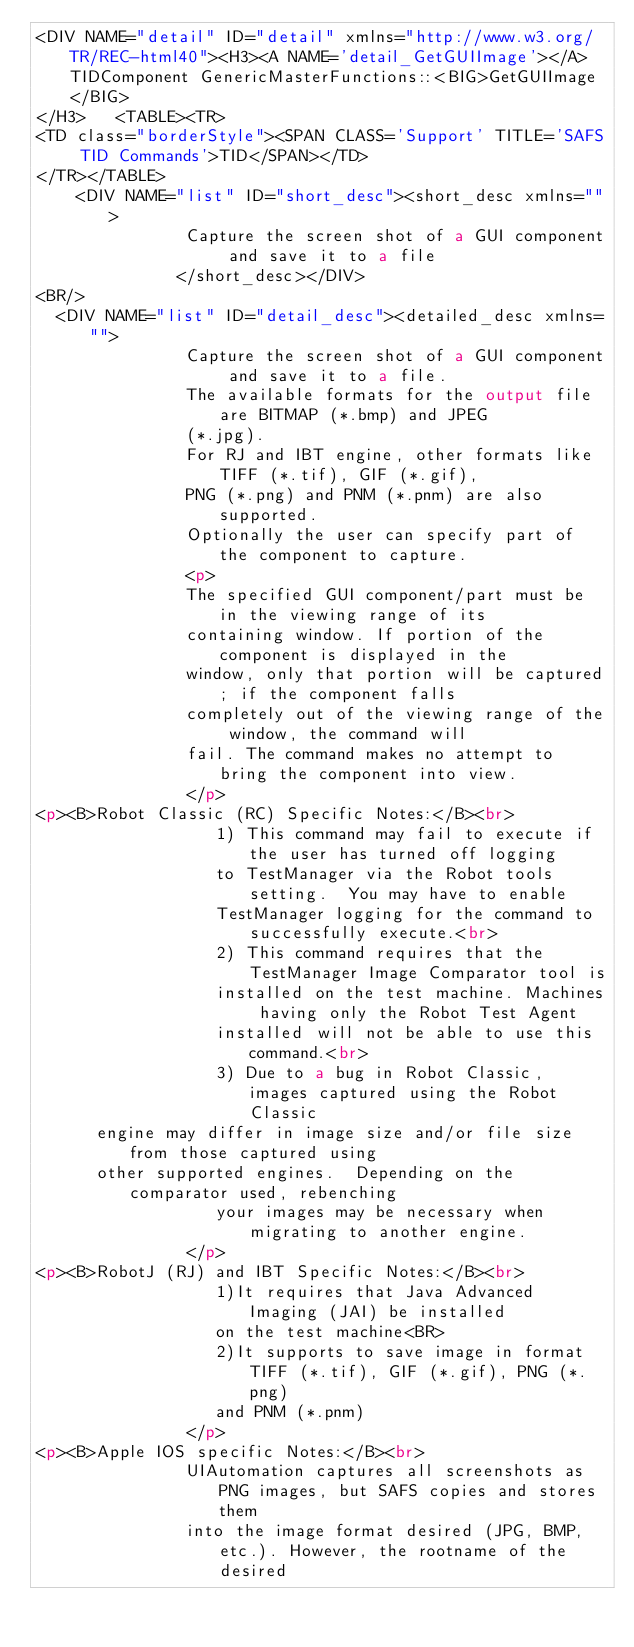<code> <loc_0><loc_0><loc_500><loc_500><_HTML_><DIV NAME="detail" ID="detail" xmlns="http://www.w3.org/TR/REC-html40"><H3><A NAME='detail_GetGUIImage'></A>TIDComponent GenericMasterFunctions::<BIG>GetGUIImage</BIG>
</H3>   <TABLE><TR>
<TD class="borderStyle"><SPAN CLASS='Support' TITLE='SAFS TID Commands'>TID</SPAN></TD>
</TR></TABLE>
	  <DIV NAME="list" ID="short_desc"><short_desc xmlns="">
               Capture the screen shot of a GUI component and save it to a file
              </short_desc></DIV>
<BR/>
	<DIV NAME="list" ID="detail_desc"><detailed_desc xmlns="">
               Capture the screen shot of a GUI component and save it to a file.
               The available formats for the output file are BITMAP (*.bmp) and JPEG
               (*.jpg). 
               For RJ and IBT engine, other formats like TIFF (*.tif), GIF (*.gif), 
               PNG (*.png) and PNM (*.pnm) are also supported.
               Optionally the user can specify part of the component to capture.
               <p>
               The specified GUI component/part must be in the viewing range of its 
               containing window. If portion of the component is displayed in the 
               window, only that portion will be captured; if the component falls
               completely out of the viewing range of the window, the command will 
               fail. The command makes no attempt to bring the component into view.
               </p>
<p><B>Robot Classic (RC) Specific Notes:</B><br>  
               		1) This command may fail to execute if the user has turned off logging 
              	 	to TestManager via the Robot tools setting.  You may have to enable 
               		TestManager logging for the command to successfully execute.<br>
               		2) This command requires that the TestManager Image Comparator tool is
               		installed on the test machine. Machines having only the Robot Test Agent
               		installed will not be able to use this command.<br>
               		3) Due to a bug in Robot Classic, images captured using the Robot Classic
			engine may differ in image size and/or file size from those captured using 
			other supported engines.  Depending on the comparator used, rebenching
               		your images may be necessary when migrating to another engine.
               </p>
<p><B>RobotJ (RJ) and IBT Specific Notes:</B><br>
               		1)It requires that Java Advanced Imaging (JAI) be installed
               		on the test machine<BR>
               		2)It supports to save image in format TIFF (*.tif), GIF (*.gif), PNG (*.png)
               		and PNM (*.pnm) 
               </p>
<p><B>Apple IOS specific Notes:</B><br>
               UIAutomation captures all screenshots as PNG images, but SAFS copies and stores them 
               into the image format desired (JPG, BMP, etc.). However, the rootname of the desired </code> 